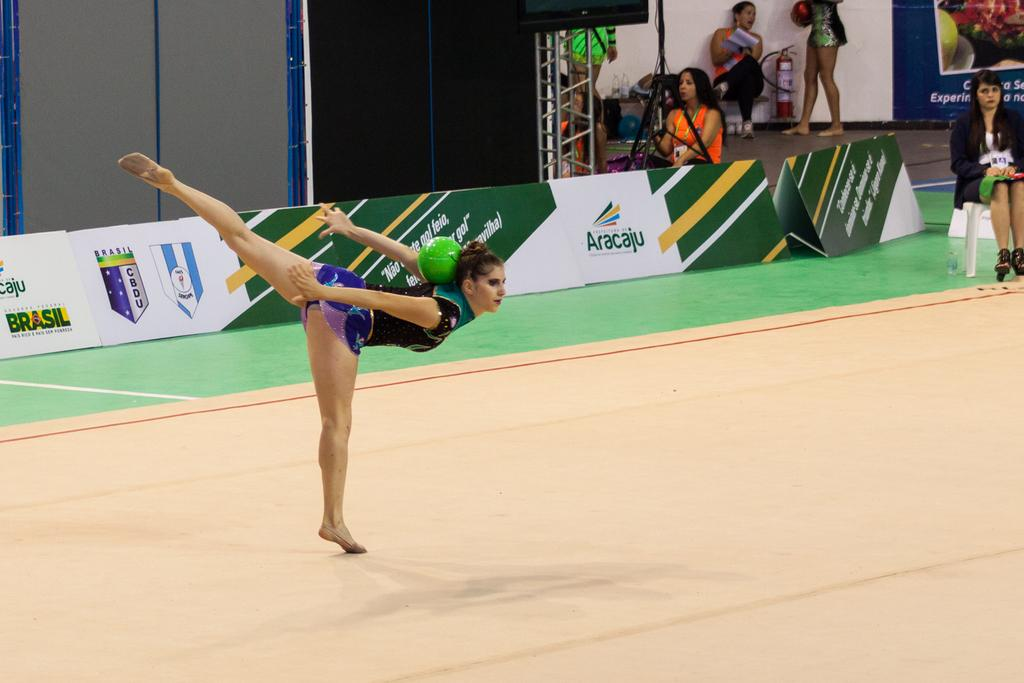Provide a one-sentence caption for the provided image. A gymnast performs a floor routine at the Aracaju games. 